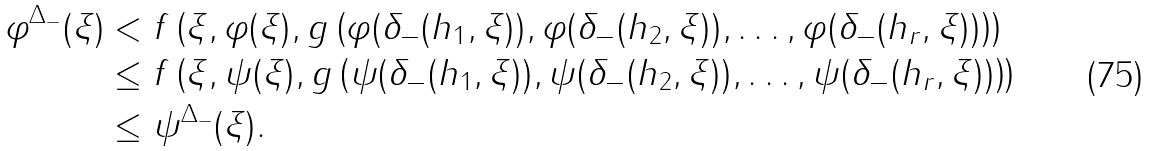<formula> <loc_0><loc_0><loc_500><loc_500>\varphi ^ { \Delta _ { - } } ( \xi ) & < f \left ( \xi , \varphi ( \xi ) , g \left ( \varphi ( \delta _ { - } ( h _ { 1 } , \xi ) ) , \varphi ( \delta _ { - } ( h _ { 2 } , \xi ) ) , \dots , \varphi ( \delta _ { - } ( h _ { r } , \xi ) ) \right ) \right ) \\ & \leq f \left ( \xi , \psi ( \xi ) , g \left ( \psi ( \delta _ { - } ( h _ { 1 } , \xi ) ) , \psi ( \delta _ { - } ( h _ { 2 } , \xi ) ) , \dots , \psi ( \delta _ { - } ( h _ { r } , \xi ) ) \right ) \right ) \\ & \leq \psi ^ { \Delta _ { - } } ( \xi ) .</formula> 